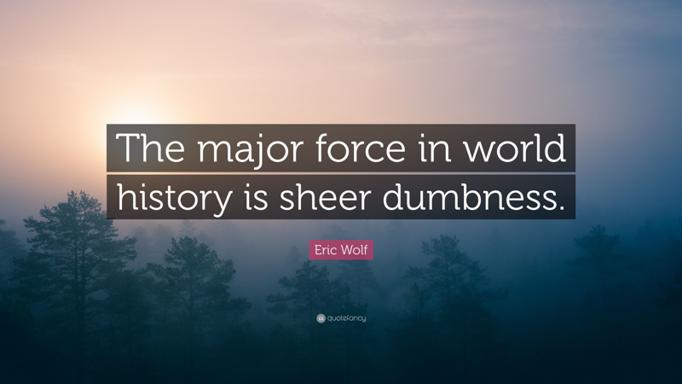How does the image's foggy forest backdrop relate to the quote by Eric Wolf? The foggy forest backdrop in the image can be seen as a metaphor for the 'sheer dumbness' mentioned by Eric Wolf. It symbolizes how unclear, confusing situations or lack of clear visibility (understanding) in decision-making can lead to significant, perhaps unintended consequences in world history. Could the serene yet obscured landscape suggest anything about passive attitudes in history? Yes, the serene yet obscured landscape might imply that a passive, unobservant attitude towards critical events and decisions can contribute to the 'sheer dumbness' impacting historical outcomes. It suggests that being passive or complacent, much like viewing a foggy landscape without action, might prevent individuals and societies from clearly seeing and hence adequately addressing crucial issues. 